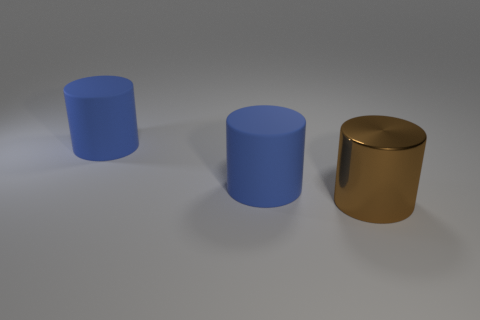Subtract all shiny cylinders. How many cylinders are left? 2 Subtract all brown cylinders. How many cylinders are left? 2 Subtract 0 cyan cubes. How many objects are left? 3 Subtract 1 cylinders. How many cylinders are left? 2 Subtract all green cylinders. Subtract all gray cubes. How many cylinders are left? 3 Subtract all brown balls. How many brown cylinders are left? 1 Subtract all brown metal blocks. Subtract all blue rubber cylinders. How many objects are left? 1 Add 2 big matte objects. How many big matte objects are left? 4 Add 3 tiny blue matte blocks. How many tiny blue matte blocks exist? 3 Add 2 blue cylinders. How many objects exist? 5 